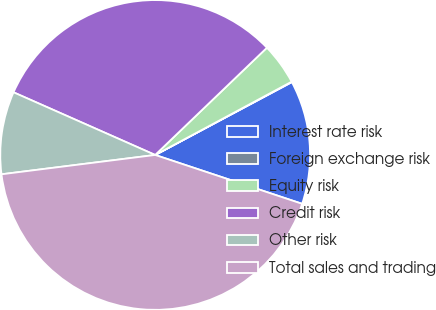Convert chart to OTSL. <chart><loc_0><loc_0><loc_500><loc_500><pie_chart><fcel>Interest rate risk<fcel>Foreign exchange risk<fcel>Equity risk<fcel>Credit risk<fcel>Other risk<fcel>Total sales and trading<nl><fcel>12.9%<fcel>0.05%<fcel>4.33%<fcel>31.2%<fcel>8.62%<fcel>42.9%<nl></chart> 